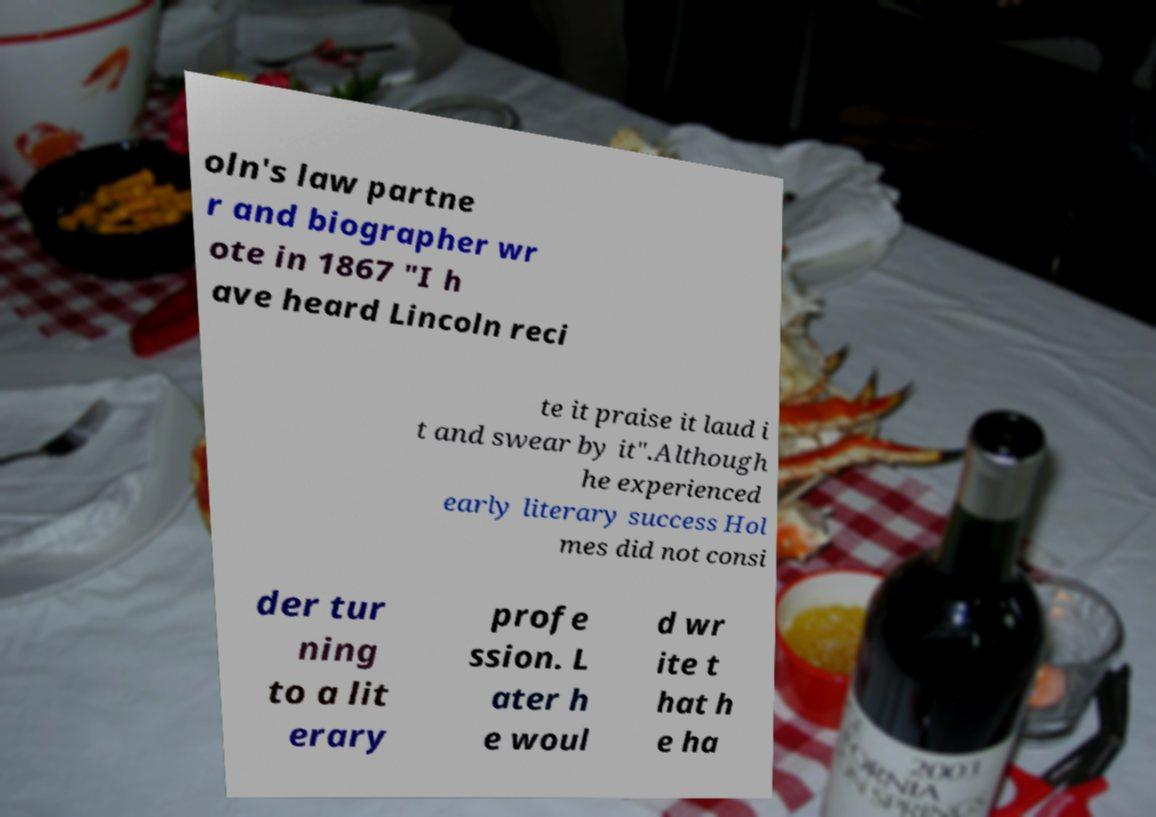Could you extract and type out the text from this image? oln's law partne r and biographer wr ote in 1867 "I h ave heard Lincoln reci te it praise it laud i t and swear by it".Although he experienced early literary success Hol mes did not consi der tur ning to a lit erary profe ssion. L ater h e woul d wr ite t hat h e ha 